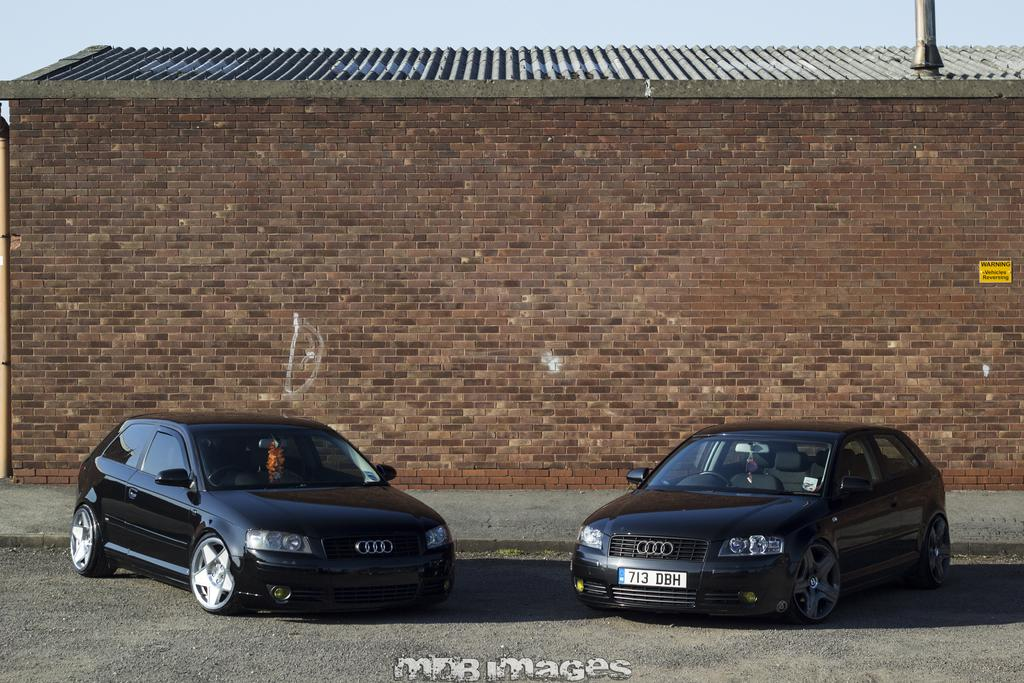How many cars are visible in the image? There are two cars in the image. Where are the cars located? The cars are on the road. What is behind the cars in the image? There is a brick wall behind the cars. What type of skirt is the band wearing while performing near the cars? There is no band or skirt present in the image; it only features two cars on the road with a brick wall in the background. 